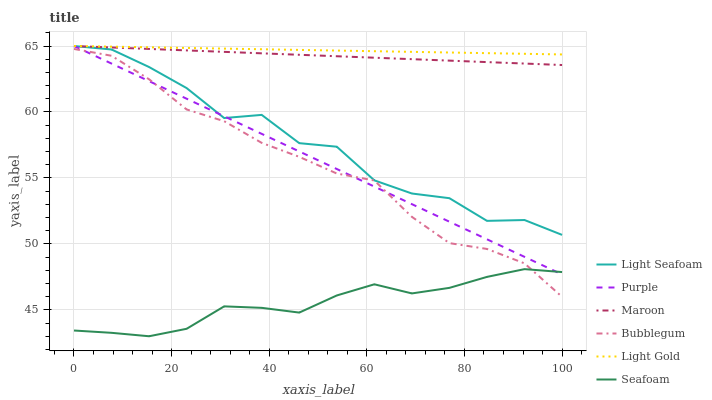Does Seafoam have the minimum area under the curve?
Answer yes or no. Yes. Does Light Gold have the maximum area under the curve?
Answer yes or no. Yes. Does Bubblegum have the minimum area under the curve?
Answer yes or no. No. Does Bubblegum have the maximum area under the curve?
Answer yes or no. No. Is Purple the smoothest?
Answer yes or no. Yes. Is Light Seafoam the roughest?
Answer yes or no. Yes. Is Seafoam the smoothest?
Answer yes or no. No. Is Seafoam the roughest?
Answer yes or no. No. Does Bubblegum have the lowest value?
Answer yes or no. No. Does Light Gold have the highest value?
Answer yes or no. Yes. Does Bubblegum have the highest value?
Answer yes or no. No. Is Seafoam less than Maroon?
Answer yes or no. Yes. Is Maroon greater than Seafoam?
Answer yes or no. Yes. Does Seafoam intersect Purple?
Answer yes or no. Yes. Is Seafoam less than Purple?
Answer yes or no. No. Is Seafoam greater than Purple?
Answer yes or no. No. Does Seafoam intersect Maroon?
Answer yes or no. No. 